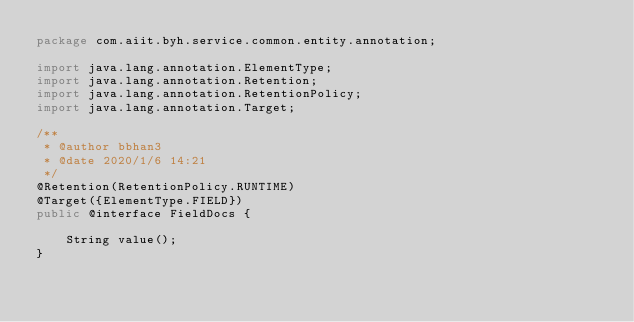<code> <loc_0><loc_0><loc_500><loc_500><_Java_>package com.aiit.byh.service.common.entity.annotation;

import java.lang.annotation.ElementType;
import java.lang.annotation.Retention;
import java.lang.annotation.RetentionPolicy;
import java.lang.annotation.Target;

/**
 * @author bbhan3
 * @date 2020/1/6 14:21
 */
@Retention(RetentionPolicy.RUNTIME)
@Target({ElementType.FIELD})
public @interface FieldDocs {

    String value();
}
</code> 